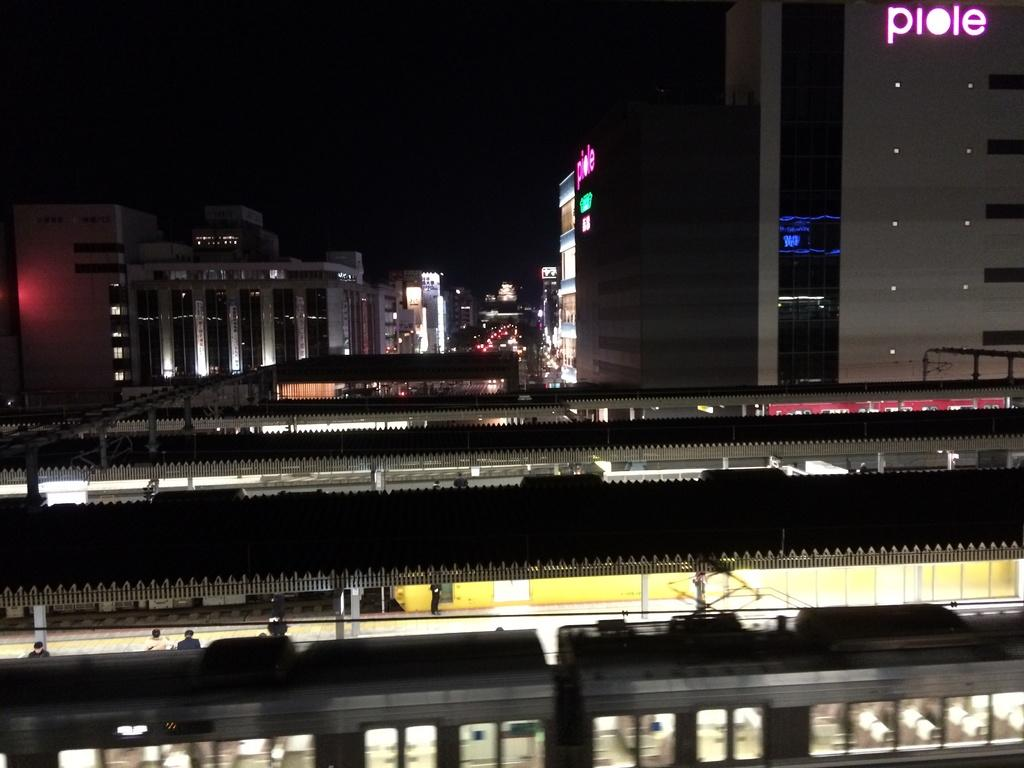<image>
Offer a succinct explanation of the picture presented. A building with "piole" written on it sits behind the train tracks. 